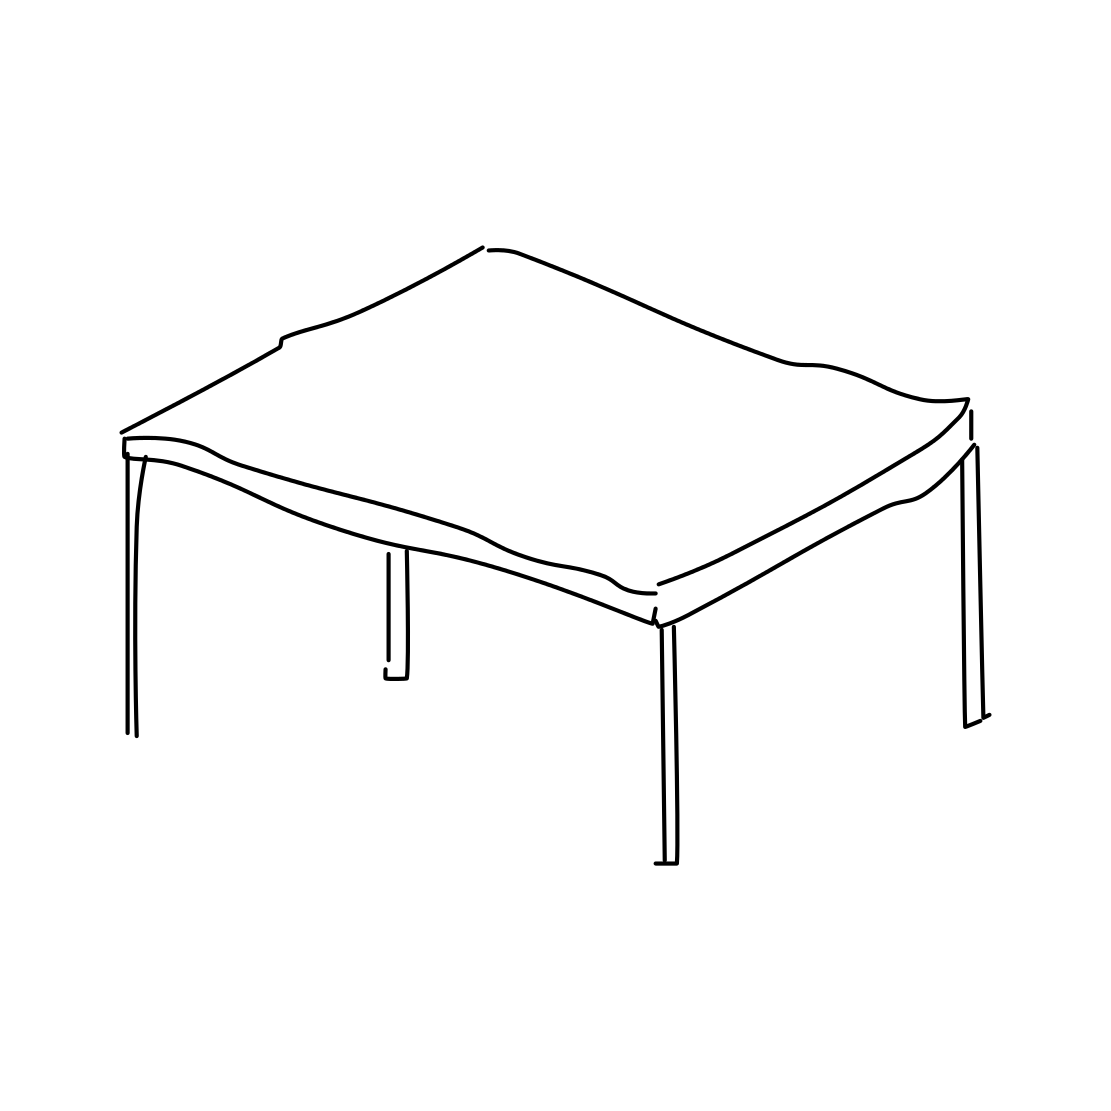In the scene, is a bell in it? No 